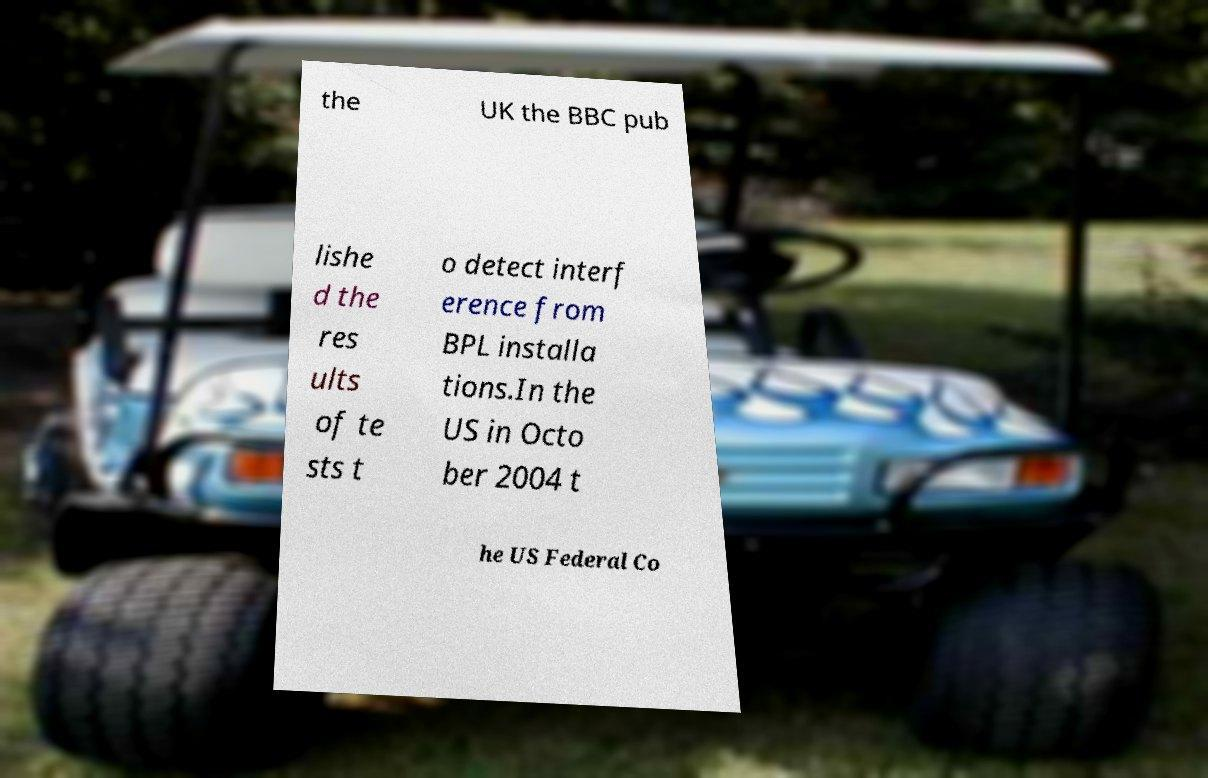Could you assist in decoding the text presented in this image and type it out clearly? the UK the BBC pub lishe d the res ults of te sts t o detect interf erence from BPL installa tions.In the US in Octo ber 2004 t he US Federal Co 